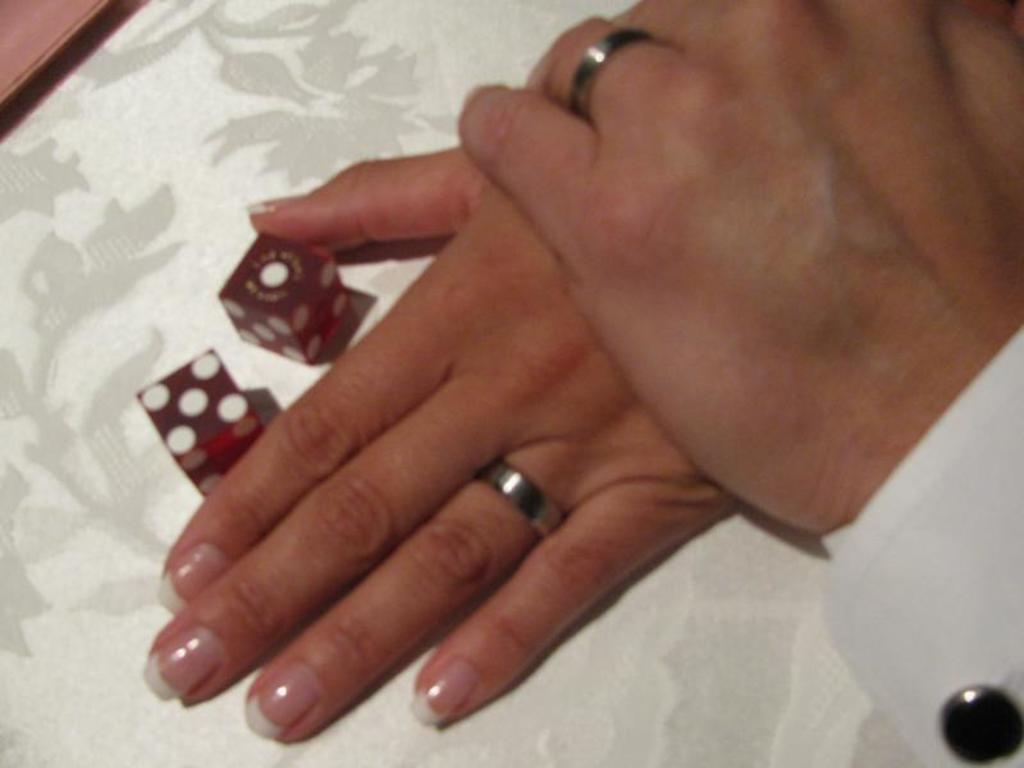What can be seen in the image that belongs to a person? There is a person's hand in the image. What object is present in the image that is typically used in games? There is a red dice in the image. On what surface is the red dice placed? The red dice is on a surface. What type of protest is happening in the image? There is no protest present in the image; it features a person's hand and a red dice on a surface. What time of day does the image depict, and how does the person feel about it? The image does not depict a specific time of day or convey any emotions, as it only shows a person's hand and a red dice on a surface. 